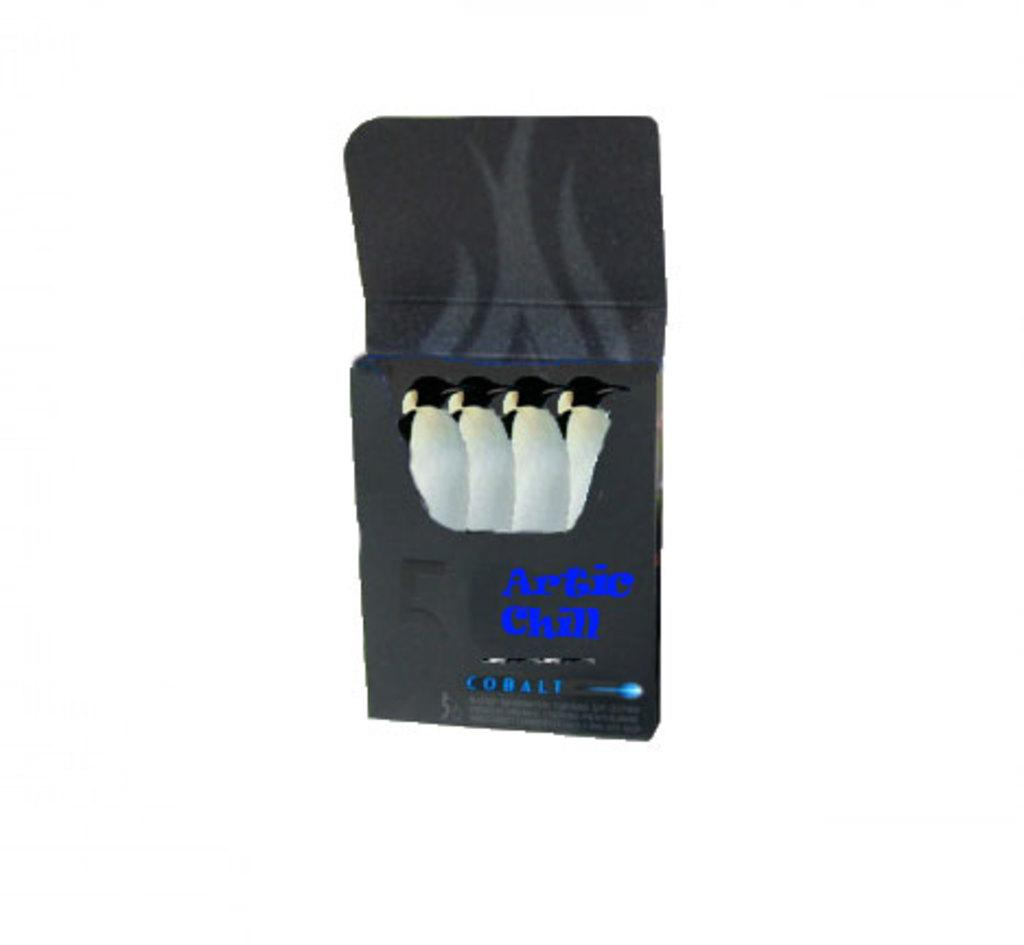<image>
Create a compact narrative representing the image presented. Four penguins in a black box that is labeled Artic Chill. 